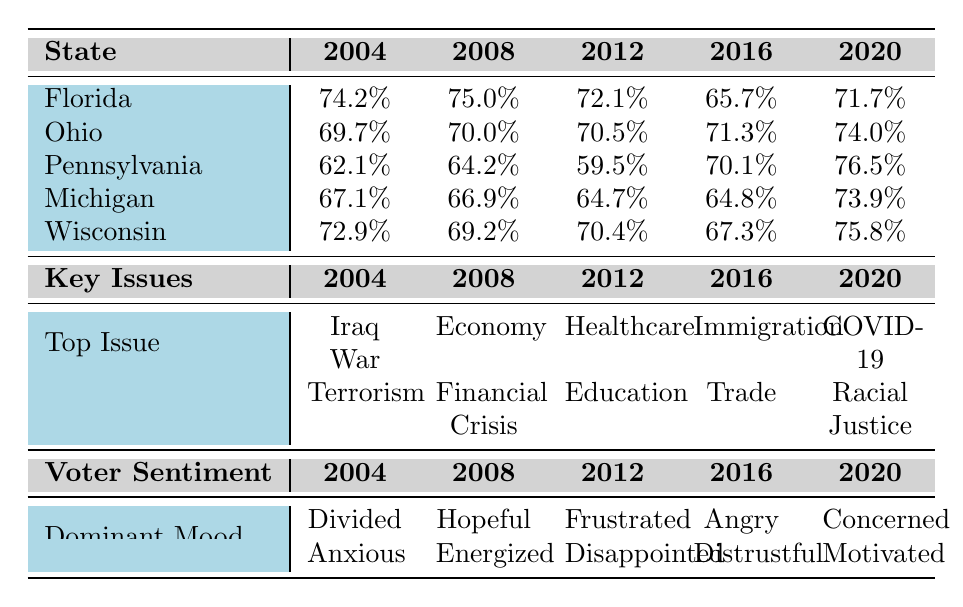What was the voter turnout rate in Florida for the 2016 election? According to the table, the voter turnout rate in Florida for the 2016 election is listed as 65.7%.
Answer: 65.7% Which swing state had the highest voter turnout in the 2020 election? In the 2020 election, Pennsylvania had the highest voter turnout rate at 76.5%, according to the table.
Answer: Pennsylvania What is the average voter turnout rate for Ohio across all elections? To find the average for Ohio, add up all the turnout rates (69.7 + 70.0 + 70.5 + 71.3 + 74.0) = 355.5. Then divide by the number of elections (5), resulting in an average of 71.1%.
Answer: 71.1% Was there an increase in voter turnout from 2012 to 2020 in Michigan? In 2012, the turnout rate for Michigan was 64.7%, and in 2020 it was 73.9%. Since 73.9% is greater than 64.7%, there was an increase in turnout.
Answer: Yes How did the voter turnout in Pennsylvania change from 2004 to 2020? The voter turnout in Pennsylvania was 62.1% in 2004 and rose to 76.5% in 2020. This indicates an increase of 14.4 percentage points (76.5 - 62.1).
Answer: Increased by 14.4 percentage points What was the dominant voter sentiment in Wisconsin during the 2004 election? According to the table, the dominant voter sentiment in Wisconsin during the 2004 election was "Worried."
Answer: Worried Which key issue was most prominent in the 2016 election across the swing states? The key issue listed for the 2016 election across all swing states is "Immigration."
Answer: Immigration In which election did Michigan see the lowest voter turnout rate and what was that rate? The lowest voter turnout rate in Michigan was in the 2012 election at 64.7%.
Answer: 64.7% Was distrust a voter sentiment in any state during the 2016 election? Yes, the sentiment "Distrustful" is listed in the voter sentiment for the 2016 election, indicating that at least some voters felt that way.
Answer: Yes How does the voter turnout rate in Florida compare to that in Wisconsin for the year 2008? The turnout rate in Florida in 2008 was 75.0%, while in Wisconsin, it was 69.2%. Florida's rate is higher by 5.8 percentage points (75.0 - 69.2).
Answer: Florida's rate is higher by 5.8 percentage points 